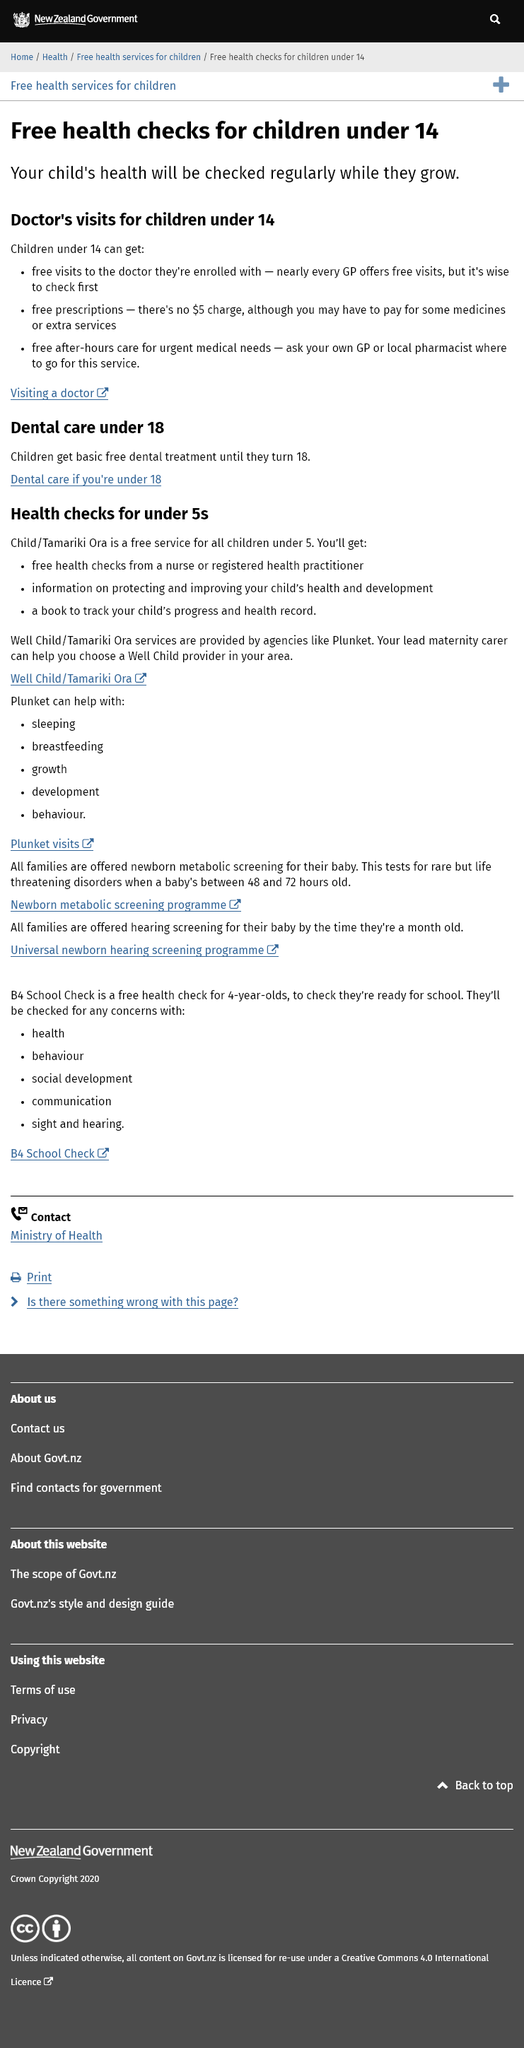Specify some key components in this picture. If you are under 18 years old, you are eligible for free dental care. The answer is yes, but there are some exclusions. The free healthchecks are provided for children under the age of 14. 